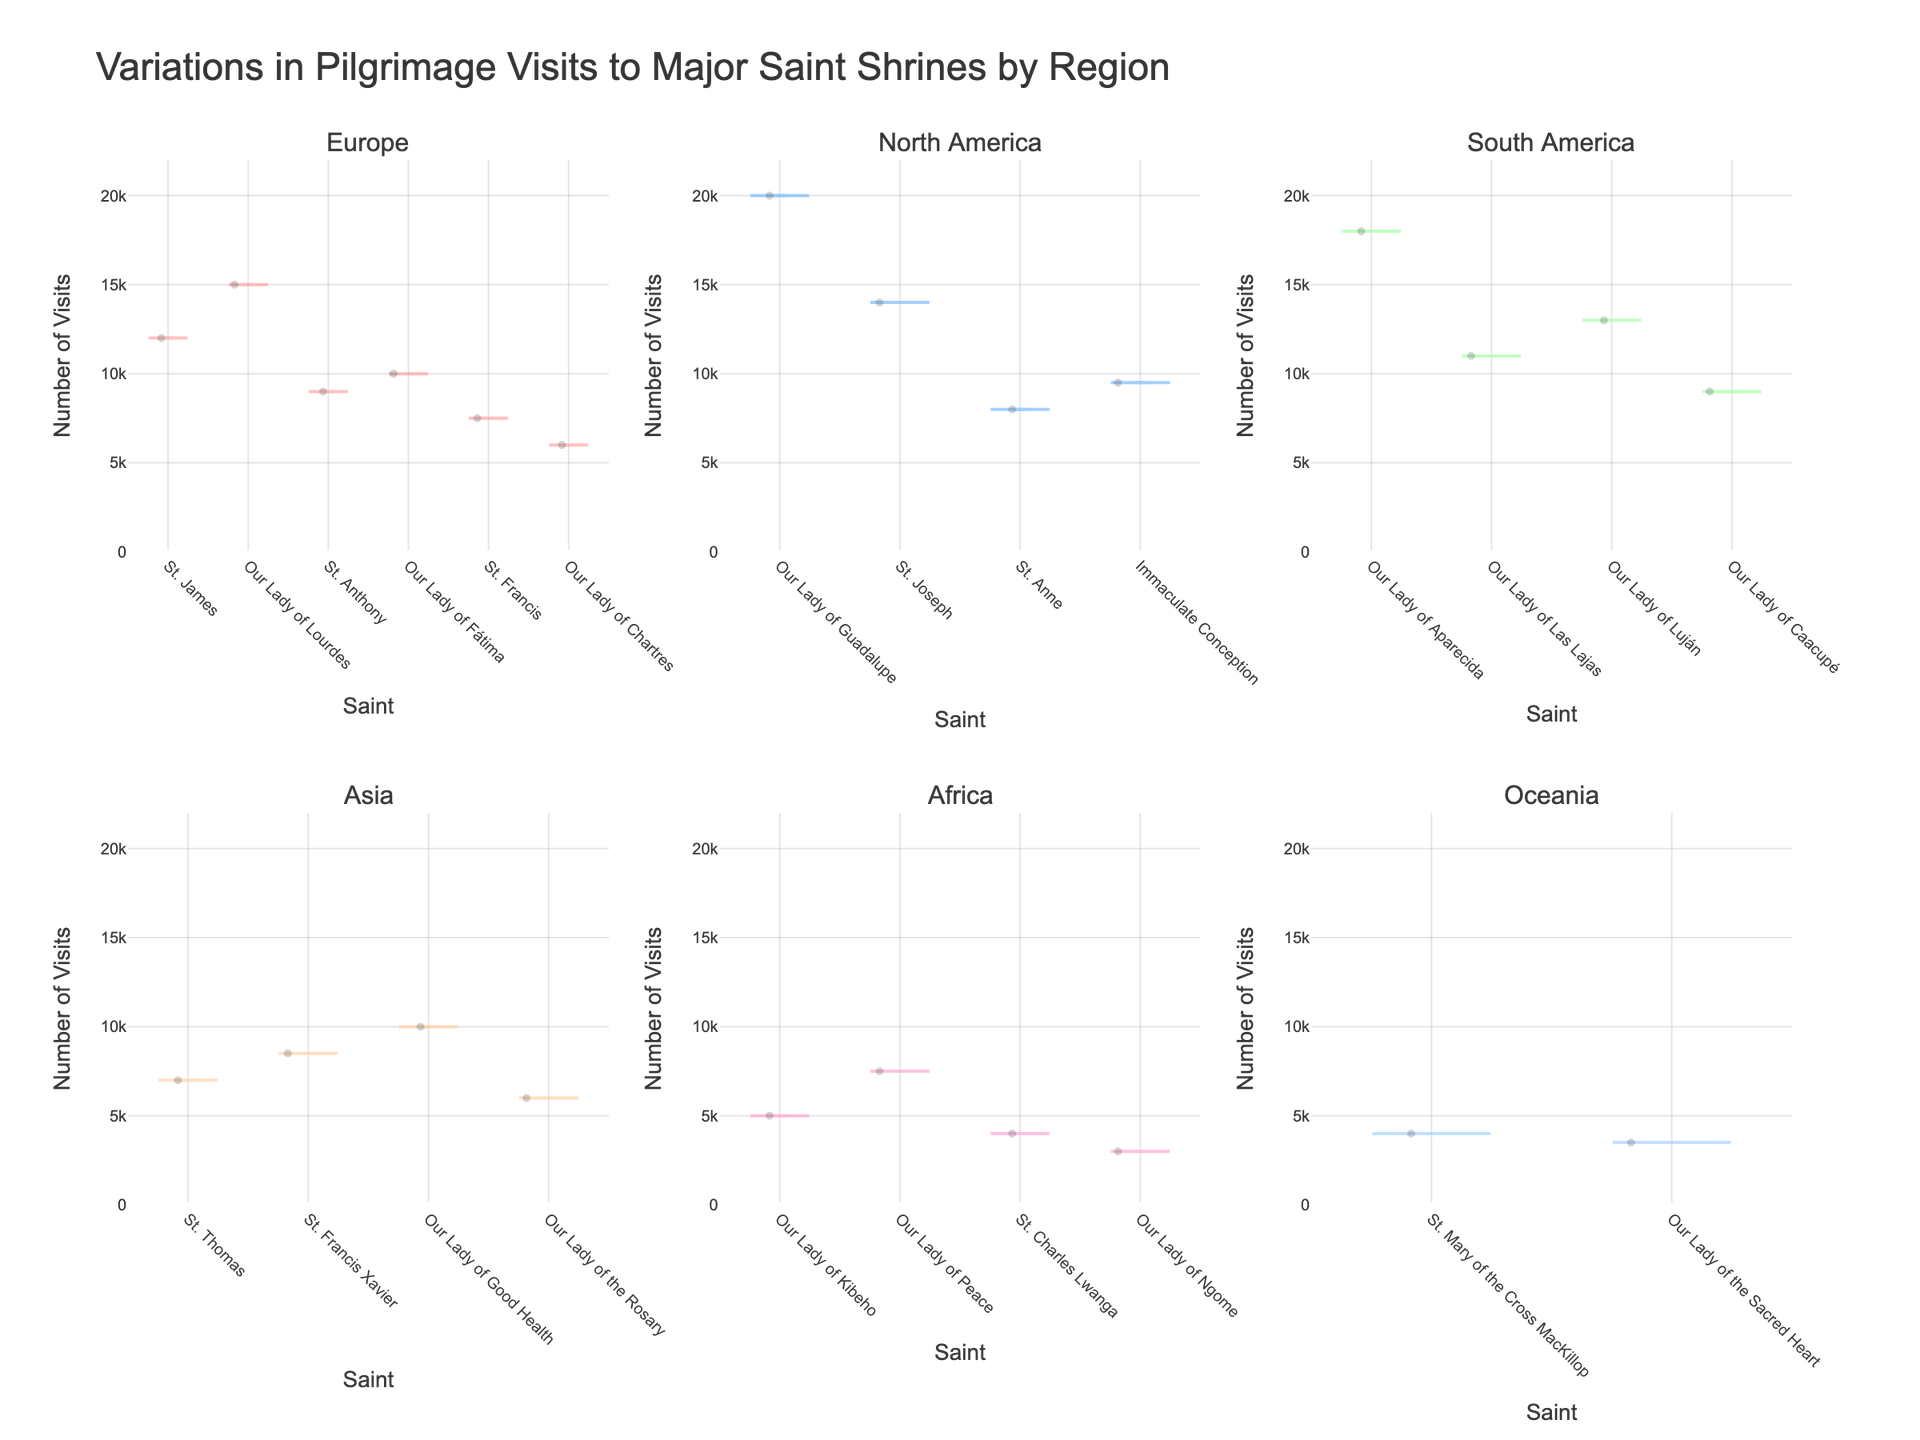What is the title of the chart? The title of the chart is located at the top and provides an overview of the data presented.
Answer: Variations in Pilgrimage Visits to Major Saint Shrines by Region How many regions are represented in the chart? The chart has individual plots for each region, which are specified in the subplot titles. Counting these titles tells us the number of regions.
Answer: 6 Which region has the highest number of pilgrimage visits for a single shrine, and which shrine is it? By examining the y-axis values for the peaks in each subplot, we can see that North America has the highest single value at 20,000 visits for the Our Lady of Guadalupe shrine.
Answer: North America, Our Lady of Guadalupe What is the range of the y-axis values in the chart? The y-axis range is given at the sides of each plot. By checking this axis, we see that it goes from 0 to slightly above the maximum value found in the data (20,000).
Answer: 0 to 22,000 Which region appears to have the least variance in visits among its shrines? To determine this, we look for the region where the shapes of the violin plots are most compressed, indicating lower variance. Africa's shrines have visits clustered closely, showing less variance.
Answer: Africa Compare the number of visits to shrines of "Our Lady of Fátima" and "St. Francis" in Europe. Which shrine has more visits? In the Europe subplot, we find the two corresponding shrines and compare their y-axis values. Our Lady of Fátima has 10,000 visits, while St. Francis has 7,500.
Answer: Our Lady of Fátima Which saint's shrine in Asia has the most visits, and how many visits does it have? Looking at the Asia subplot, we find and compare the highest peaks for each saint. Our Lady of Velankanni shrine has the highest number at 10,000 visits.
Answer: Our Lady of Good Health, 10,000 How many saints are represented in the North America subplot? Count the number of distinct saint names on the x-axis of the North America subplot.
Answer: 4 Which region shows the highest difference in the number of visits between its most visited and least visited shrine? To determine this, find the range of visits (maximum minus minimum) for the shrines in each region and identify the region with the largest range. North America shows the highest difference, with visits ranging from 8,000 (Shrine of Saint Anne) to 20,000 (Our Lady of Guadalupe).
Answer: North America 